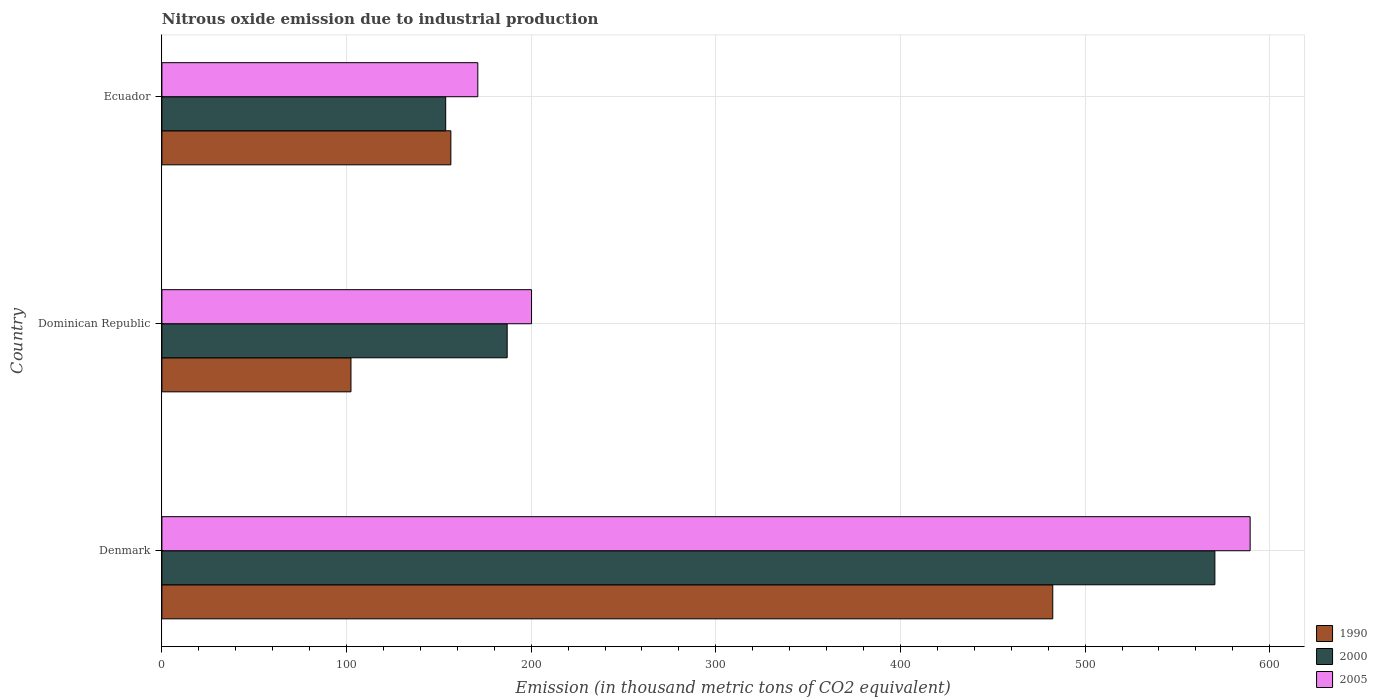Are the number of bars per tick equal to the number of legend labels?
Provide a short and direct response. Yes. Are the number of bars on each tick of the Y-axis equal?
Your answer should be very brief. Yes. What is the label of the 3rd group of bars from the top?
Keep it short and to the point. Denmark. In how many cases, is the number of bars for a given country not equal to the number of legend labels?
Provide a short and direct response. 0. What is the amount of nitrous oxide emitted in 1990 in Dominican Republic?
Ensure brevity in your answer.  102.4. Across all countries, what is the maximum amount of nitrous oxide emitted in 2005?
Your response must be concise. 589.4. Across all countries, what is the minimum amount of nitrous oxide emitted in 2000?
Make the answer very short. 153.7. In which country was the amount of nitrous oxide emitted in 1990 minimum?
Give a very brief answer. Dominican Republic. What is the total amount of nitrous oxide emitted in 2000 in the graph?
Offer a very short reply. 911. What is the difference between the amount of nitrous oxide emitted in 1990 in Denmark and that in Ecuador?
Ensure brevity in your answer.  326. What is the difference between the amount of nitrous oxide emitted in 1990 in Ecuador and the amount of nitrous oxide emitted in 2005 in Dominican Republic?
Make the answer very short. -43.7. What is the average amount of nitrous oxide emitted in 2000 per country?
Provide a succinct answer. 303.67. What is the difference between the amount of nitrous oxide emitted in 1990 and amount of nitrous oxide emitted in 2000 in Ecuador?
Your answer should be compact. 2.8. In how many countries, is the amount of nitrous oxide emitted in 1990 greater than 80 thousand metric tons?
Your answer should be very brief. 3. What is the ratio of the amount of nitrous oxide emitted in 1990 in Denmark to that in Dominican Republic?
Your answer should be very brief. 4.71. What is the difference between the highest and the second highest amount of nitrous oxide emitted in 1990?
Your answer should be very brief. 326. What is the difference between the highest and the lowest amount of nitrous oxide emitted in 2005?
Give a very brief answer. 418.3. What does the 1st bar from the top in Dominican Republic represents?
Ensure brevity in your answer.  2005. Is it the case that in every country, the sum of the amount of nitrous oxide emitted in 2000 and amount of nitrous oxide emitted in 1990 is greater than the amount of nitrous oxide emitted in 2005?
Ensure brevity in your answer.  Yes. Are all the bars in the graph horizontal?
Ensure brevity in your answer.  Yes. What is the difference between two consecutive major ticks on the X-axis?
Your response must be concise. 100. Are the values on the major ticks of X-axis written in scientific E-notation?
Your answer should be very brief. No. Does the graph contain any zero values?
Your response must be concise. No. Where does the legend appear in the graph?
Keep it short and to the point. Bottom right. What is the title of the graph?
Your answer should be very brief. Nitrous oxide emission due to industrial production. Does "1960" appear as one of the legend labels in the graph?
Provide a short and direct response. No. What is the label or title of the X-axis?
Your answer should be very brief. Emission (in thousand metric tons of CO2 equivalent). What is the Emission (in thousand metric tons of CO2 equivalent) in 1990 in Denmark?
Give a very brief answer. 482.5. What is the Emission (in thousand metric tons of CO2 equivalent) in 2000 in Denmark?
Your response must be concise. 570.3. What is the Emission (in thousand metric tons of CO2 equivalent) in 2005 in Denmark?
Offer a very short reply. 589.4. What is the Emission (in thousand metric tons of CO2 equivalent) of 1990 in Dominican Republic?
Your answer should be very brief. 102.4. What is the Emission (in thousand metric tons of CO2 equivalent) of 2000 in Dominican Republic?
Offer a very short reply. 187. What is the Emission (in thousand metric tons of CO2 equivalent) in 2005 in Dominican Republic?
Your answer should be very brief. 200.2. What is the Emission (in thousand metric tons of CO2 equivalent) of 1990 in Ecuador?
Your answer should be compact. 156.5. What is the Emission (in thousand metric tons of CO2 equivalent) of 2000 in Ecuador?
Your answer should be very brief. 153.7. What is the Emission (in thousand metric tons of CO2 equivalent) in 2005 in Ecuador?
Provide a succinct answer. 171.1. Across all countries, what is the maximum Emission (in thousand metric tons of CO2 equivalent) in 1990?
Give a very brief answer. 482.5. Across all countries, what is the maximum Emission (in thousand metric tons of CO2 equivalent) in 2000?
Provide a succinct answer. 570.3. Across all countries, what is the maximum Emission (in thousand metric tons of CO2 equivalent) of 2005?
Keep it short and to the point. 589.4. Across all countries, what is the minimum Emission (in thousand metric tons of CO2 equivalent) in 1990?
Your answer should be compact. 102.4. Across all countries, what is the minimum Emission (in thousand metric tons of CO2 equivalent) in 2000?
Provide a short and direct response. 153.7. Across all countries, what is the minimum Emission (in thousand metric tons of CO2 equivalent) in 2005?
Offer a very short reply. 171.1. What is the total Emission (in thousand metric tons of CO2 equivalent) in 1990 in the graph?
Your response must be concise. 741.4. What is the total Emission (in thousand metric tons of CO2 equivalent) of 2000 in the graph?
Offer a terse response. 911. What is the total Emission (in thousand metric tons of CO2 equivalent) of 2005 in the graph?
Your answer should be compact. 960.7. What is the difference between the Emission (in thousand metric tons of CO2 equivalent) in 1990 in Denmark and that in Dominican Republic?
Ensure brevity in your answer.  380.1. What is the difference between the Emission (in thousand metric tons of CO2 equivalent) of 2000 in Denmark and that in Dominican Republic?
Offer a very short reply. 383.3. What is the difference between the Emission (in thousand metric tons of CO2 equivalent) in 2005 in Denmark and that in Dominican Republic?
Make the answer very short. 389.2. What is the difference between the Emission (in thousand metric tons of CO2 equivalent) in 1990 in Denmark and that in Ecuador?
Offer a terse response. 326. What is the difference between the Emission (in thousand metric tons of CO2 equivalent) of 2000 in Denmark and that in Ecuador?
Give a very brief answer. 416.6. What is the difference between the Emission (in thousand metric tons of CO2 equivalent) of 2005 in Denmark and that in Ecuador?
Provide a short and direct response. 418.3. What is the difference between the Emission (in thousand metric tons of CO2 equivalent) in 1990 in Dominican Republic and that in Ecuador?
Keep it short and to the point. -54.1. What is the difference between the Emission (in thousand metric tons of CO2 equivalent) in 2000 in Dominican Republic and that in Ecuador?
Offer a very short reply. 33.3. What is the difference between the Emission (in thousand metric tons of CO2 equivalent) in 2005 in Dominican Republic and that in Ecuador?
Your response must be concise. 29.1. What is the difference between the Emission (in thousand metric tons of CO2 equivalent) in 1990 in Denmark and the Emission (in thousand metric tons of CO2 equivalent) in 2000 in Dominican Republic?
Ensure brevity in your answer.  295.5. What is the difference between the Emission (in thousand metric tons of CO2 equivalent) of 1990 in Denmark and the Emission (in thousand metric tons of CO2 equivalent) of 2005 in Dominican Republic?
Make the answer very short. 282.3. What is the difference between the Emission (in thousand metric tons of CO2 equivalent) in 2000 in Denmark and the Emission (in thousand metric tons of CO2 equivalent) in 2005 in Dominican Republic?
Provide a short and direct response. 370.1. What is the difference between the Emission (in thousand metric tons of CO2 equivalent) in 1990 in Denmark and the Emission (in thousand metric tons of CO2 equivalent) in 2000 in Ecuador?
Your answer should be very brief. 328.8. What is the difference between the Emission (in thousand metric tons of CO2 equivalent) of 1990 in Denmark and the Emission (in thousand metric tons of CO2 equivalent) of 2005 in Ecuador?
Provide a short and direct response. 311.4. What is the difference between the Emission (in thousand metric tons of CO2 equivalent) of 2000 in Denmark and the Emission (in thousand metric tons of CO2 equivalent) of 2005 in Ecuador?
Your response must be concise. 399.2. What is the difference between the Emission (in thousand metric tons of CO2 equivalent) in 1990 in Dominican Republic and the Emission (in thousand metric tons of CO2 equivalent) in 2000 in Ecuador?
Your answer should be very brief. -51.3. What is the difference between the Emission (in thousand metric tons of CO2 equivalent) in 1990 in Dominican Republic and the Emission (in thousand metric tons of CO2 equivalent) in 2005 in Ecuador?
Make the answer very short. -68.7. What is the difference between the Emission (in thousand metric tons of CO2 equivalent) of 2000 in Dominican Republic and the Emission (in thousand metric tons of CO2 equivalent) of 2005 in Ecuador?
Give a very brief answer. 15.9. What is the average Emission (in thousand metric tons of CO2 equivalent) in 1990 per country?
Your answer should be very brief. 247.13. What is the average Emission (in thousand metric tons of CO2 equivalent) in 2000 per country?
Make the answer very short. 303.67. What is the average Emission (in thousand metric tons of CO2 equivalent) in 2005 per country?
Make the answer very short. 320.23. What is the difference between the Emission (in thousand metric tons of CO2 equivalent) in 1990 and Emission (in thousand metric tons of CO2 equivalent) in 2000 in Denmark?
Provide a succinct answer. -87.8. What is the difference between the Emission (in thousand metric tons of CO2 equivalent) in 1990 and Emission (in thousand metric tons of CO2 equivalent) in 2005 in Denmark?
Provide a succinct answer. -106.9. What is the difference between the Emission (in thousand metric tons of CO2 equivalent) of 2000 and Emission (in thousand metric tons of CO2 equivalent) of 2005 in Denmark?
Provide a succinct answer. -19.1. What is the difference between the Emission (in thousand metric tons of CO2 equivalent) in 1990 and Emission (in thousand metric tons of CO2 equivalent) in 2000 in Dominican Republic?
Offer a very short reply. -84.6. What is the difference between the Emission (in thousand metric tons of CO2 equivalent) in 1990 and Emission (in thousand metric tons of CO2 equivalent) in 2005 in Dominican Republic?
Ensure brevity in your answer.  -97.8. What is the difference between the Emission (in thousand metric tons of CO2 equivalent) in 1990 and Emission (in thousand metric tons of CO2 equivalent) in 2000 in Ecuador?
Make the answer very short. 2.8. What is the difference between the Emission (in thousand metric tons of CO2 equivalent) of 1990 and Emission (in thousand metric tons of CO2 equivalent) of 2005 in Ecuador?
Give a very brief answer. -14.6. What is the difference between the Emission (in thousand metric tons of CO2 equivalent) in 2000 and Emission (in thousand metric tons of CO2 equivalent) in 2005 in Ecuador?
Provide a succinct answer. -17.4. What is the ratio of the Emission (in thousand metric tons of CO2 equivalent) in 1990 in Denmark to that in Dominican Republic?
Give a very brief answer. 4.71. What is the ratio of the Emission (in thousand metric tons of CO2 equivalent) of 2000 in Denmark to that in Dominican Republic?
Your answer should be compact. 3.05. What is the ratio of the Emission (in thousand metric tons of CO2 equivalent) of 2005 in Denmark to that in Dominican Republic?
Offer a terse response. 2.94. What is the ratio of the Emission (in thousand metric tons of CO2 equivalent) of 1990 in Denmark to that in Ecuador?
Ensure brevity in your answer.  3.08. What is the ratio of the Emission (in thousand metric tons of CO2 equivalent) of 2000 in Denmark to that in Ecuador?
Your answer should be compact. 3.71. What is the ratio of the Emission (in thousand metric tons of CO2 equivalent) of 2005 in Denmark to that in Ecuador?
Keep it short and to the point. 3.44. What is the ratio of the Emission (in thousand metric tons of CO2 equivalent) of 1990 in Dominican Republic to that in Ecuador?
Give a very brief answer. 0.65. What is the ratio of the Emission (in thousand metric tons of CO2 equivalent) of 2000 in Dominican Republic to that in Ecuador?
Your answer should be very brief. 1.22. What is the ratio of the Emission (in thousand metric tons of CO2 equivalent) in 2005 in Dominican Republic to that in Ecuador?
Your answer should be very brief. 1.17. What is the difference between the highest and the second highest Emission (in thousand metric tons of CO2 equivalent) in 1990?
Offer a very short reply. 326. What is the difference between the highest and the second highest Emission (in thousand metric tons of CO2 equivalent) in 2000?
Offer a very short reply. 383.3. What is the difference between the highest and the second highest Emission (in thousand metric tons of CO2 equivalent) of 2005?
Provide a short and direct response. 389.2. What is the difference between the highest and the lowest Emission (in thousand metric tons of CO2 equivalent) of 1990?
Your answer should be very brief. 380.1. What is the difference between the highest and the lowest Emission (in thousand metric tons of CO2 equivalent) in 2000?
Your response must be concise. 416.6. What is the difference between the highest and the lowest Emission (in thousand metric tons of CO2 equivalent) in 2005?
Make the answer very short. 418.3. 